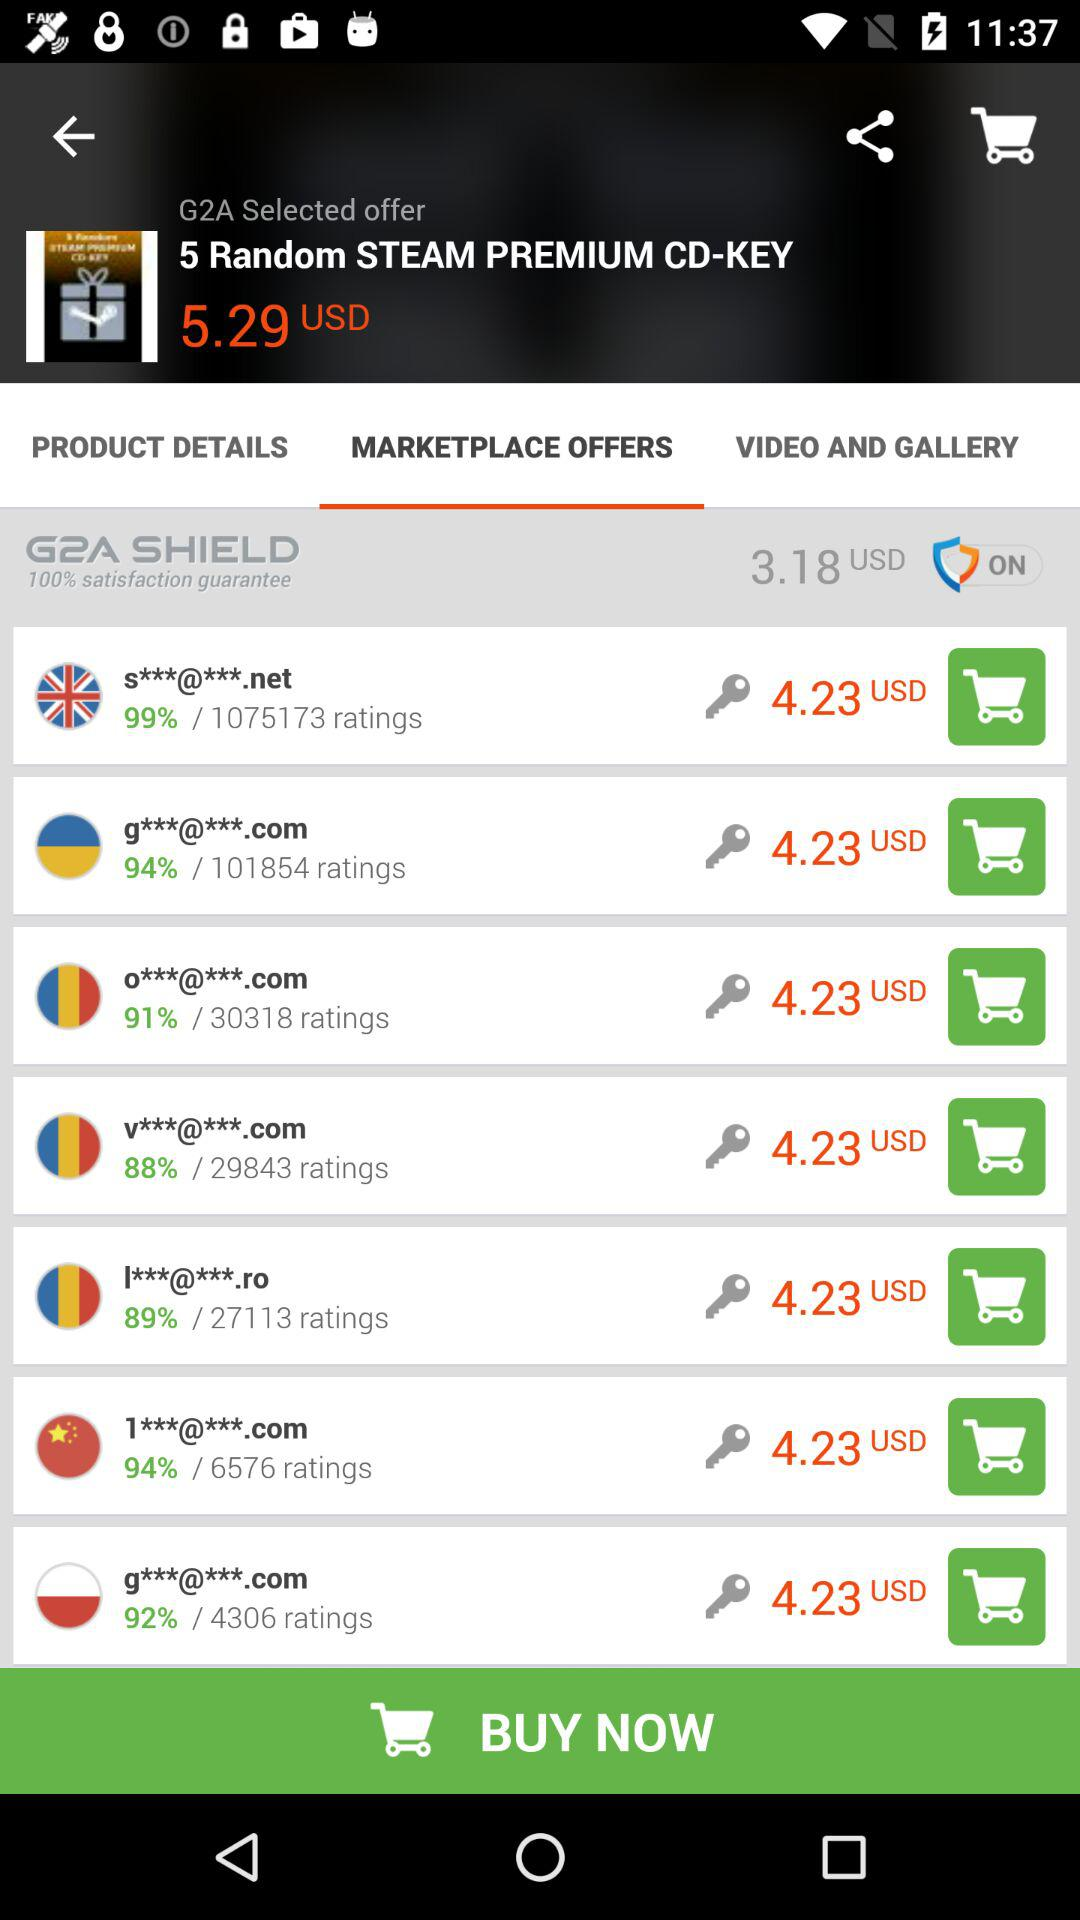How many ratings are there for "g***@***.com"? For "g***@***.com", there are 4306 ratings. 